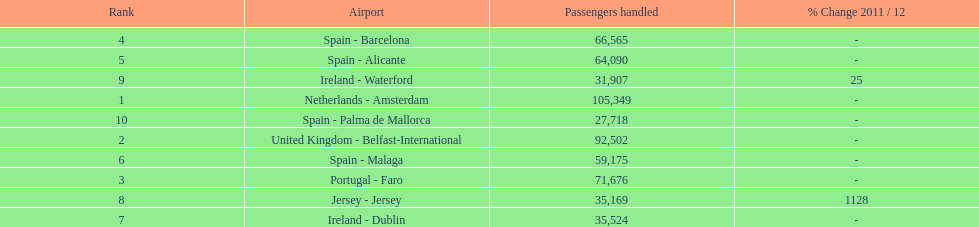How many airports in spain are among the 10 busiest routes to and from london southend airport in 2012? 4. 